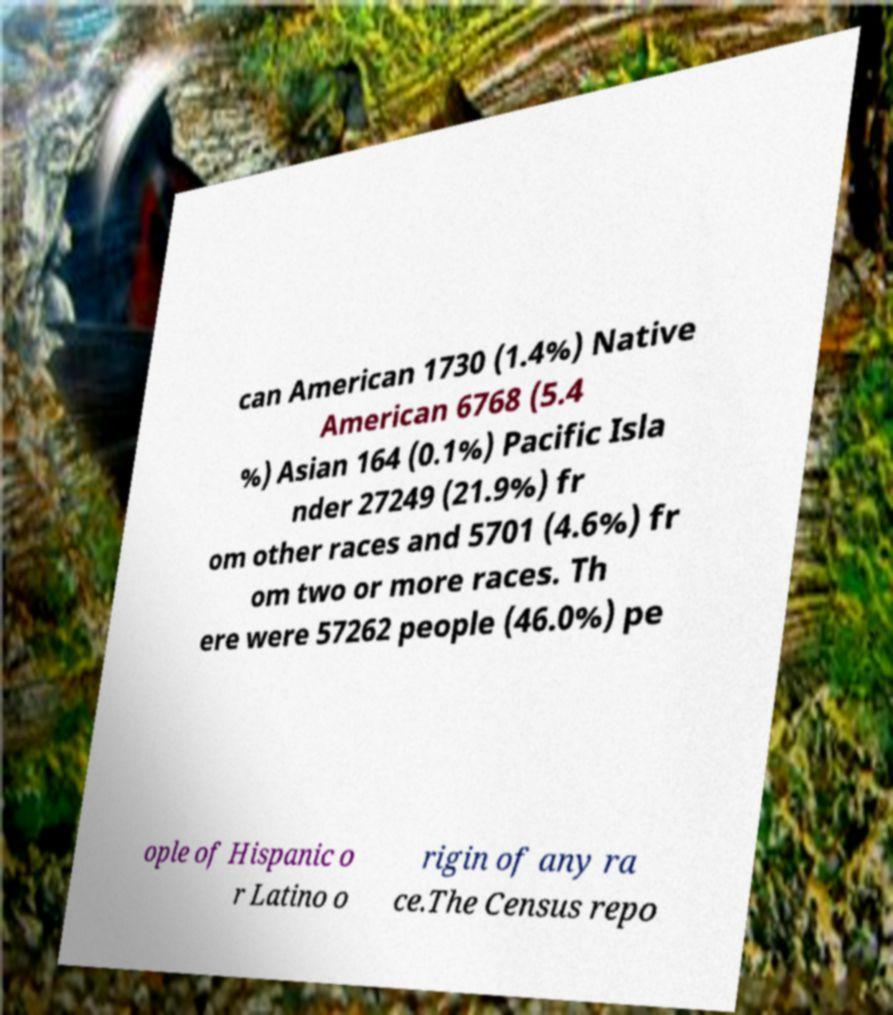For documentation purposes, I need the text within this image transcribed. Could you provide that? can American 1730 (1.4%) Native American 6768 (5.4 %) Asian 164 (0.1%) Pacific Isla nder 27249 (21.9%) fr om other races and 5701 (4.6%) fr om two or more races. Th ere were 57262 people (46.0%) pe ople of Hispanic o r Latino o rigin of any ra ce.The Census repo 